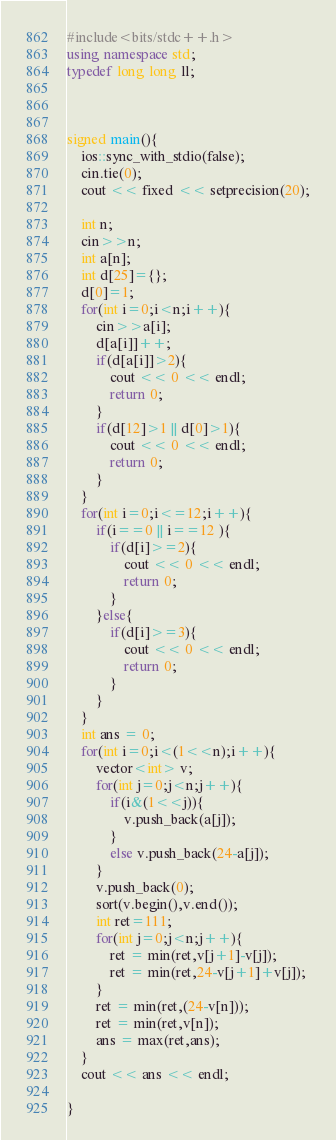Convert code to text. <code><loc_0><loc_0><loc_500><loc_500><_C++_>#include<bits/stdc++.h>
using namespace std;
typedef long long ll;



signed main(){
    ios::sync_with_stdio(false);
    cin.tie(0);
    cout << fixed << setprecision(20);
    
    int n;
    cin>>n;
    int a[n];
    int d[25]={};
    d[0]=1;
    for(int i=0;i<n;i++){
        cin>>a[i];
        d[a[i]]++;
        if(d[a[i]]>2){
            cout << 0 << endl;
            return 0;
        }
        if(d[12]>1 || d[0]>1){
            cout << 0 << endl;
            return 0;
        }
    }    
    for(int i=0;i<=12;i++){
        if(i==0 || i==12 ){
            if(d[i]>=2){
                cout << 0 << endl;
                return 0;
            }
        }else{
            if(d[i]>=3){
                cout << 0 << endl;
                return 0;
            }
        }
    }
    int ans = 0;
    for(int i=0;i<(1<<n);i++){
        vector<int> v;
        for(int j=0;j<n;j++){
            if(i&(1<<j)){
                v.push_back(a[j]);
            }
            else v.push_back(24-a[j]);
        }
        v.push_back(0);
        sort(v.begin(),v.end());
        int ret=111;
        for(int j=0;j<n;j++){
            ret = min(ret,v[j+1]-v[j]);
            ret = min(ret,24-v[j+1]+v[j]);
        }
        ret = min(ret,(24-v[n]));
        ret = min(ret,v[n]);
        ans = max(ret,ans);
    }
    cout << ans << endl;
    
}</code> 